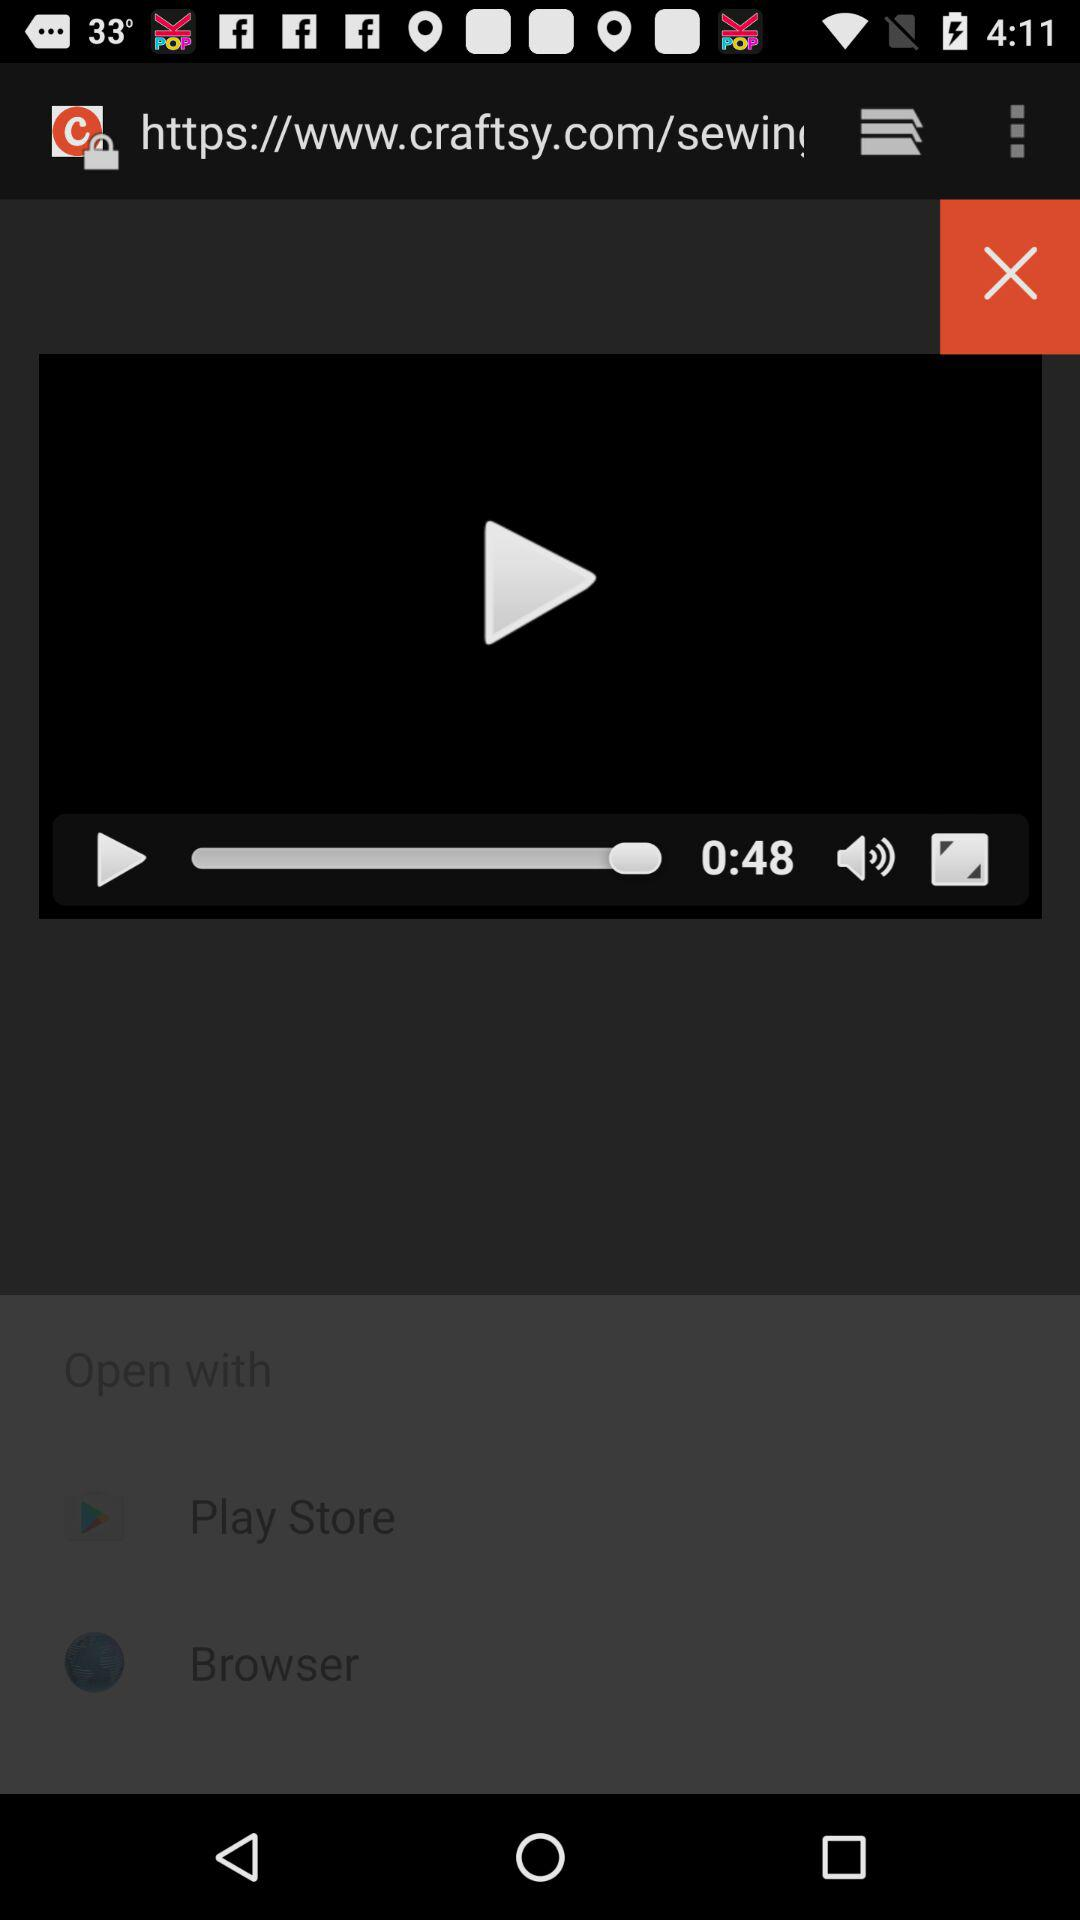What is the name of application? The name of the application is "craftsy". 